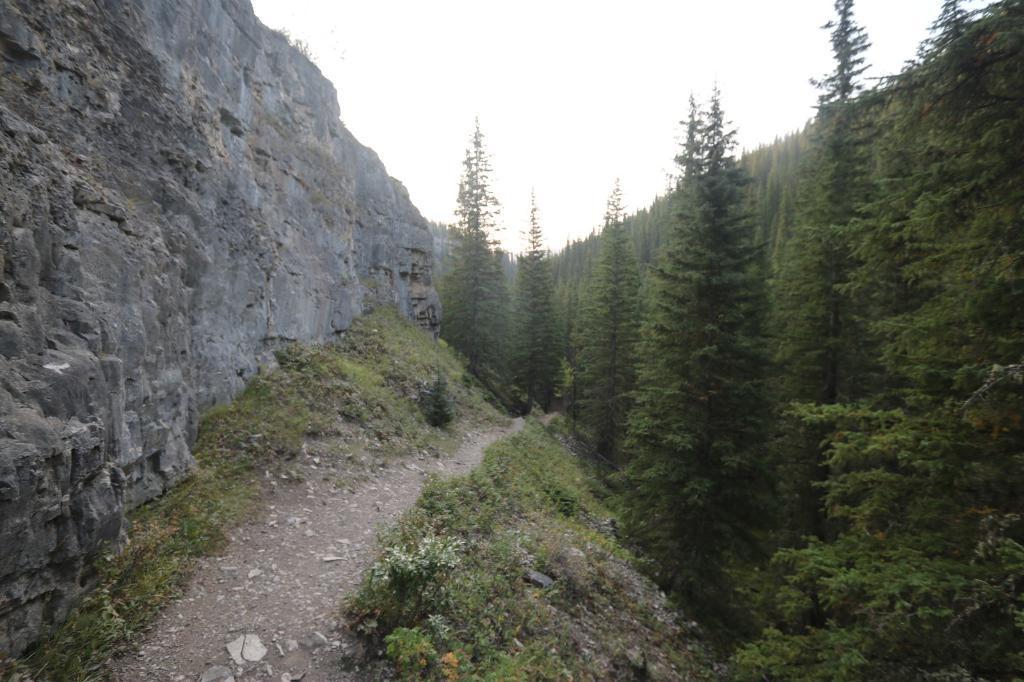Could you give a brief overview of what you see in this image? In this picture we can see so many trees and one big rock. 